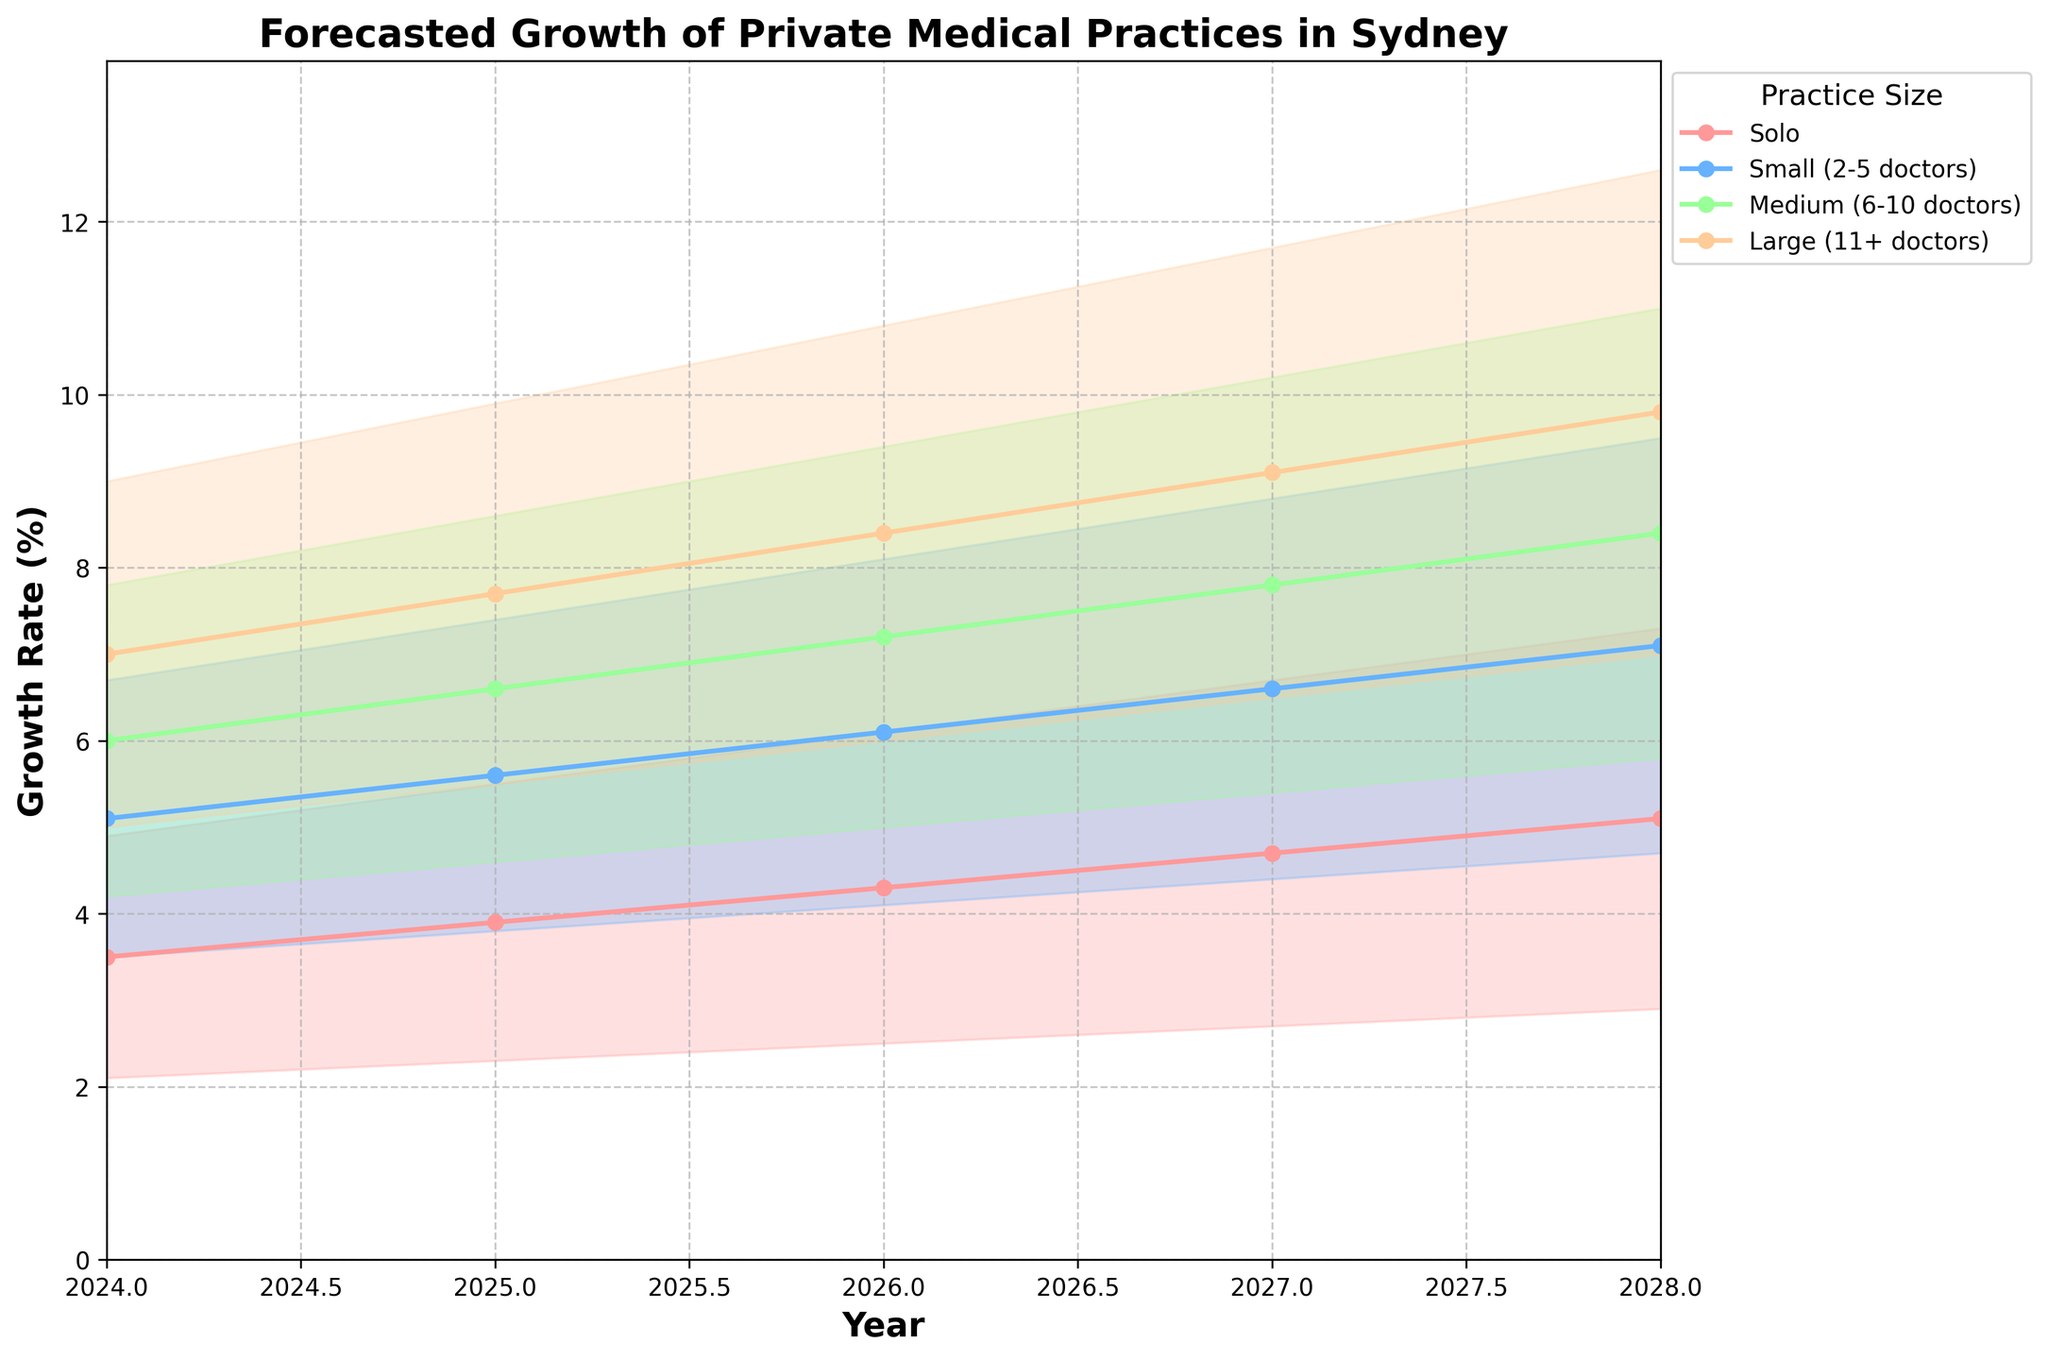What's the title of the figure? The title of the figure is displayed at the top in bold.
Answer: Forecasted Growth of Private Medical Practices in Sydney Which practice size has the highest growth rate in 2025? By looking at the 2025 data points, the "Large (11+ doctors)" practice size has the highest values for its estimates.
Answer: Large (11+ doctors) How does the growth rate of solo practices in 2024 compare to that in 2028? In 2024, the mid estimate for solo practices is 3.5%, and in 2028, it is 5.1%. The 2028 estimate is higher.
Answer: Higher in 2028 What is the expected range of growth for small practices in 2026? For 2026, the low estimate for small practices is 4.1%, and the high estimate is 8.1%. This is the expected range.
Answer: 4.1% to 8.1% In which year is the growth rate estimate for medium practices closest to 6%? Referring to the mid estimates, in 2024 the estimate for medium practices is 6.0%, which is exactly 6%.
Answer: 2024 By how much is the high estimate of growth for large practices in 2027 greater than the low estimate in the same year? The high estimate is 11.7% and the low estimate is 6.5%. Subtracting these gives 11.7% - 6.5% = 5.2%.
Answer: 5.2% What's the growth trend for solo practices from 2024 to 2028? The solo practice mid estimates consistently increase over the years: 3.5% in 2024, 3.9% in 2025, 4.3% in 2026, 4.7% in 2027, and 5.1% in 2028.
Answer: Increasing Which practice size shows the most consistent growth between 2024 and 2028? By observing the mid estimates across all practice sizes, the growth rates for "Large (11+ doctors)" show consistent increments each year.
Answer: Large (11+ doctors) How does the high estimate for medium practices in 2027 compare to the high estimate for small practices in 2028? The high estimate for medium practices in 2027 is 10.2%, and for small practices in 2028, it is 9.5%. The 2027 medium practice estimate is higher.
Answer: Higher in 2027 for medium practices 